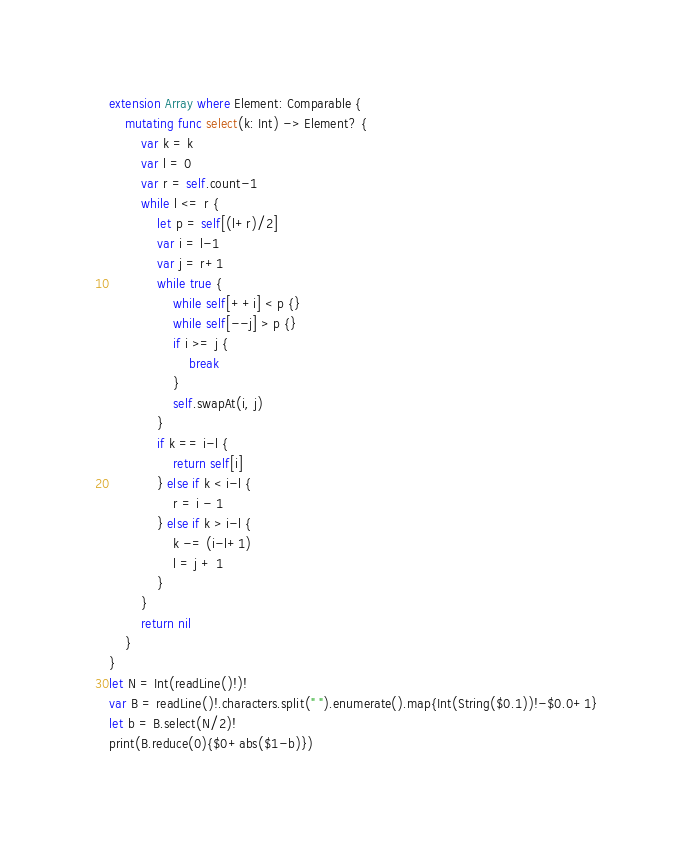<code> <loc_0><loc_0><loc_500><loc_500><_Swift_>extension Array where Element: Comparable {
    mutating func select(k: Int) -> Element? {
        var k = k
        var l = 0
        var r = self.count-1
        while l <= r {
            let p = self[(l+r)/2]
            var i = l-1
            var j = r+1
            while true {
                while self[++i] < p {}
                while self[--j] > p {}
                if i >= j {
                    break
                }
                self.swapAt(i, j)
            }
            if k == i-l {
                return self[i]
            } else if k < i-l {
                r = i - 1
            } else if k > i-l {
                k -= (i-l+1)
                l = j + 1
            }
        }
        return nil
    }
}
let N = Int(readLine()!)!
var B = readLine()!.characters.split(" ").enumerate().map{Int(String($0.1))!-$0.0+1}
let b = B.select(N/2)!
print(B.reduce(0){$0+abs($1-b)})</code> 